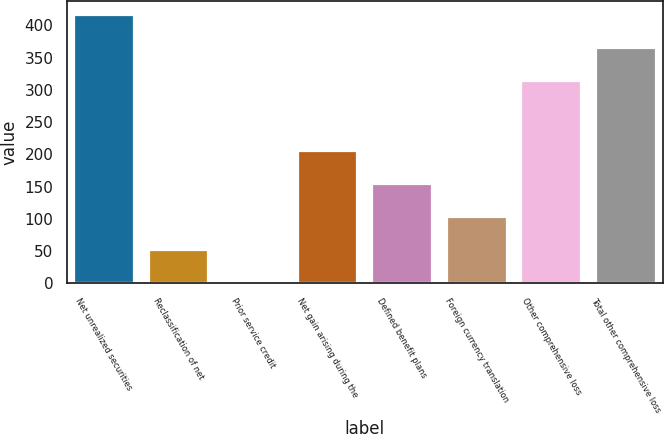<chart> <loc_0><loc_0><loc_500><loc_500><bar_chart><fcel>Net unrealized securities<fcel>Reclassification of net<fcel>Prior service credit<fcel>Net gain arising during the<fcel>Defined benefit plans<fcel>Foreign currency translation<fcel>Other comprehensive loss<fcel>Total other comprehensive loss<nl><fcel>416.4<fcel>52.2<fcel>1<fcel>205.8<fcel>154.6<fcel>103.4<fcel>314<fcel>365.2<nl></chart> 